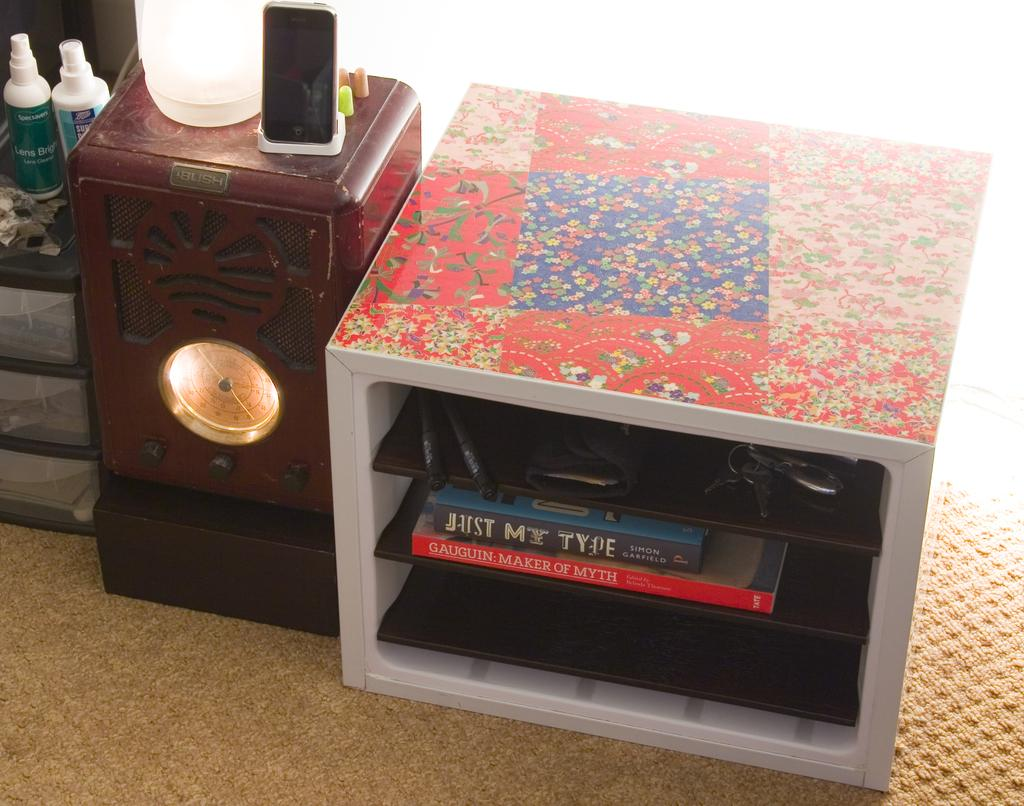Provide a one-sentence caption for the provided image. A small bookshelf with the book Just My type sits to the right of a clock. 